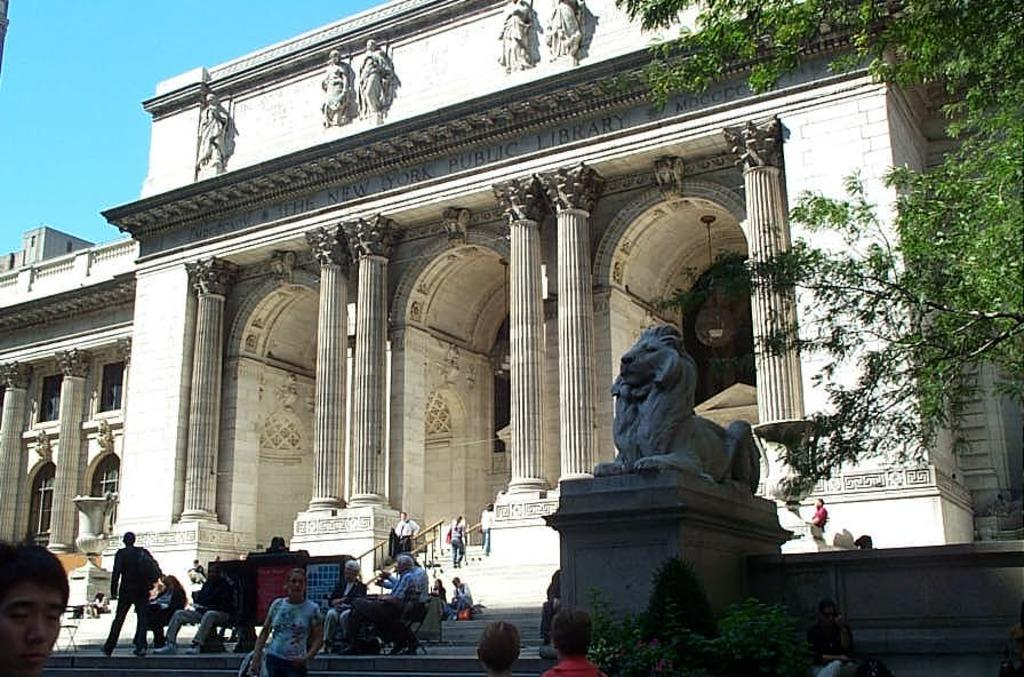How many people can be seen in the image? There are people in the image, but the exact number is not specified. What is located on a surface in the image? There is a statue on a surface in the image. What type of vegetation is present in the image? There is a plant in the image. What architectural features can be seen in the background of the image? There are pillars and a building in the background of the image. What else is present on the wall in the background of the image? There are statues on the wall in the background of the image. What can be seen in the sky in the background of the image? The sky is visible in the background of the image, and it is blue in color. What type of art can be heard in the image? There is no art present in the image that can be heard, as the image is a visual representation. What trick is being performed by the people in the image? There is no indication of a trick being performed by the people in the image. 